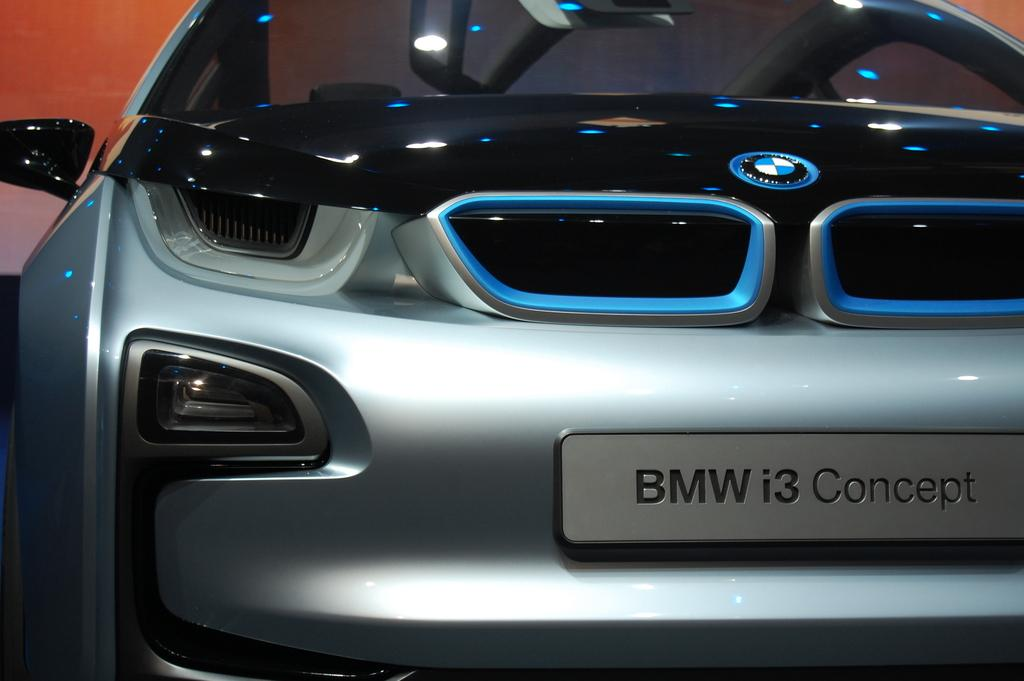What type of car is featured in the image? The image is of a BMW i3 concept car. Can you describe any specific features of the car? The car has a registration plate at the front. What is written on the registration plate? The registration plate has the text "bmw i3 concept" written on it. What color is the background of the image? The background of the image is orange. What type of industry can be seen in the background of the image? There is no industry visible in the background of the image; the background is simply orange. Can you describe the wave pattern on the car's hood? There is no wave pattern on the car's hood; the car is a BMW i3 concept, and the image does not show any wave patterns. 